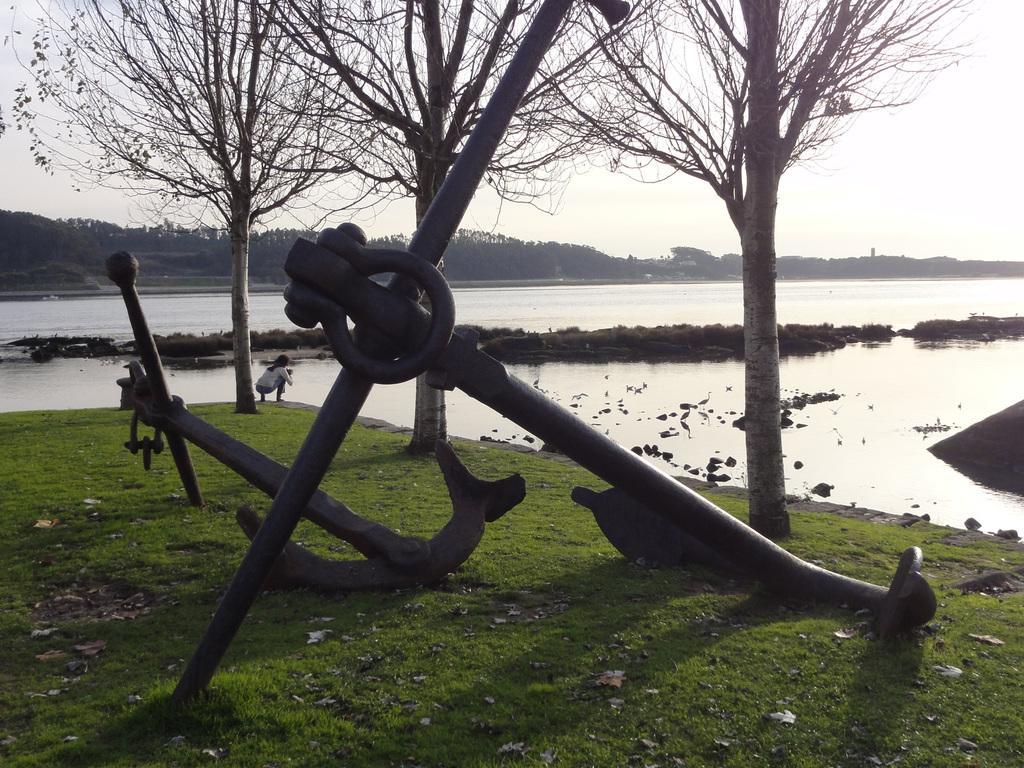What type of vegetation can be seen in the image? There are trees in the image. What natural element is visible in the image? There is water visible in the image. Can you describe the person in the image? There is a human in the image. What type of structure is present in the image? There is a metal architecture in the image. How would you describe the weather in the image? The sky is cloudy in the image. What type of ground cover is present in the image? Grass is present on the ground in the image. How many pizzas are being served by the trees in the image? There are no pizzas present in the image, and trees do not serve food. What type of nose does the human have in the image? The provided facts do not mention the human's nose, so we cannot answer this question. 